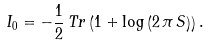<formula> <loc_0><loc_0><loc_500><loc_500>I _ { 0 } = - \frac { 1 } { 2 } \, T r \left ( 1 + \log \left ( 2 \, \pi \, S \right ) \right ) .</formula> 